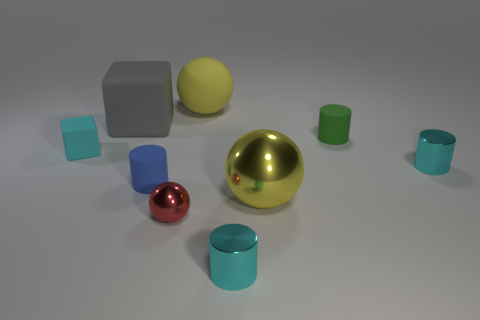Describe the lighting in the scene. The lighting in the image is soft and diffused, coming from above. There are subtle shadows under the objects, which suggests a single light source, likely positioned above and possibly slightly in front of the arrangement of objects. 